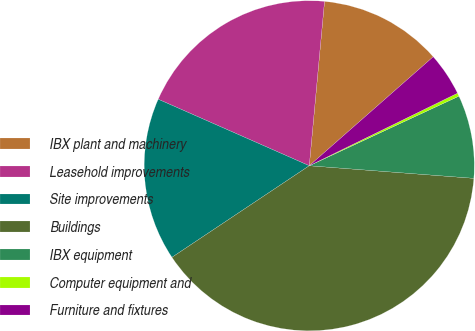<chart> <loc_0><loc_0><loc_500><loc_500><pie_chart><fcel>IBX plant and machinery<fcel>Leasehold improvements<fcel>Site improvements<fcel>Buildings<fcel>IBX equipment<fcel>Computer equipment and<fcel>Furniture and fixtures<nl><fcel>12.05%<fcel>19.87%<fcel>15.96%<fcel>39.42%<fcel>8.14%<fcel>0.32%<fcel>4.23%<nl></chart> 